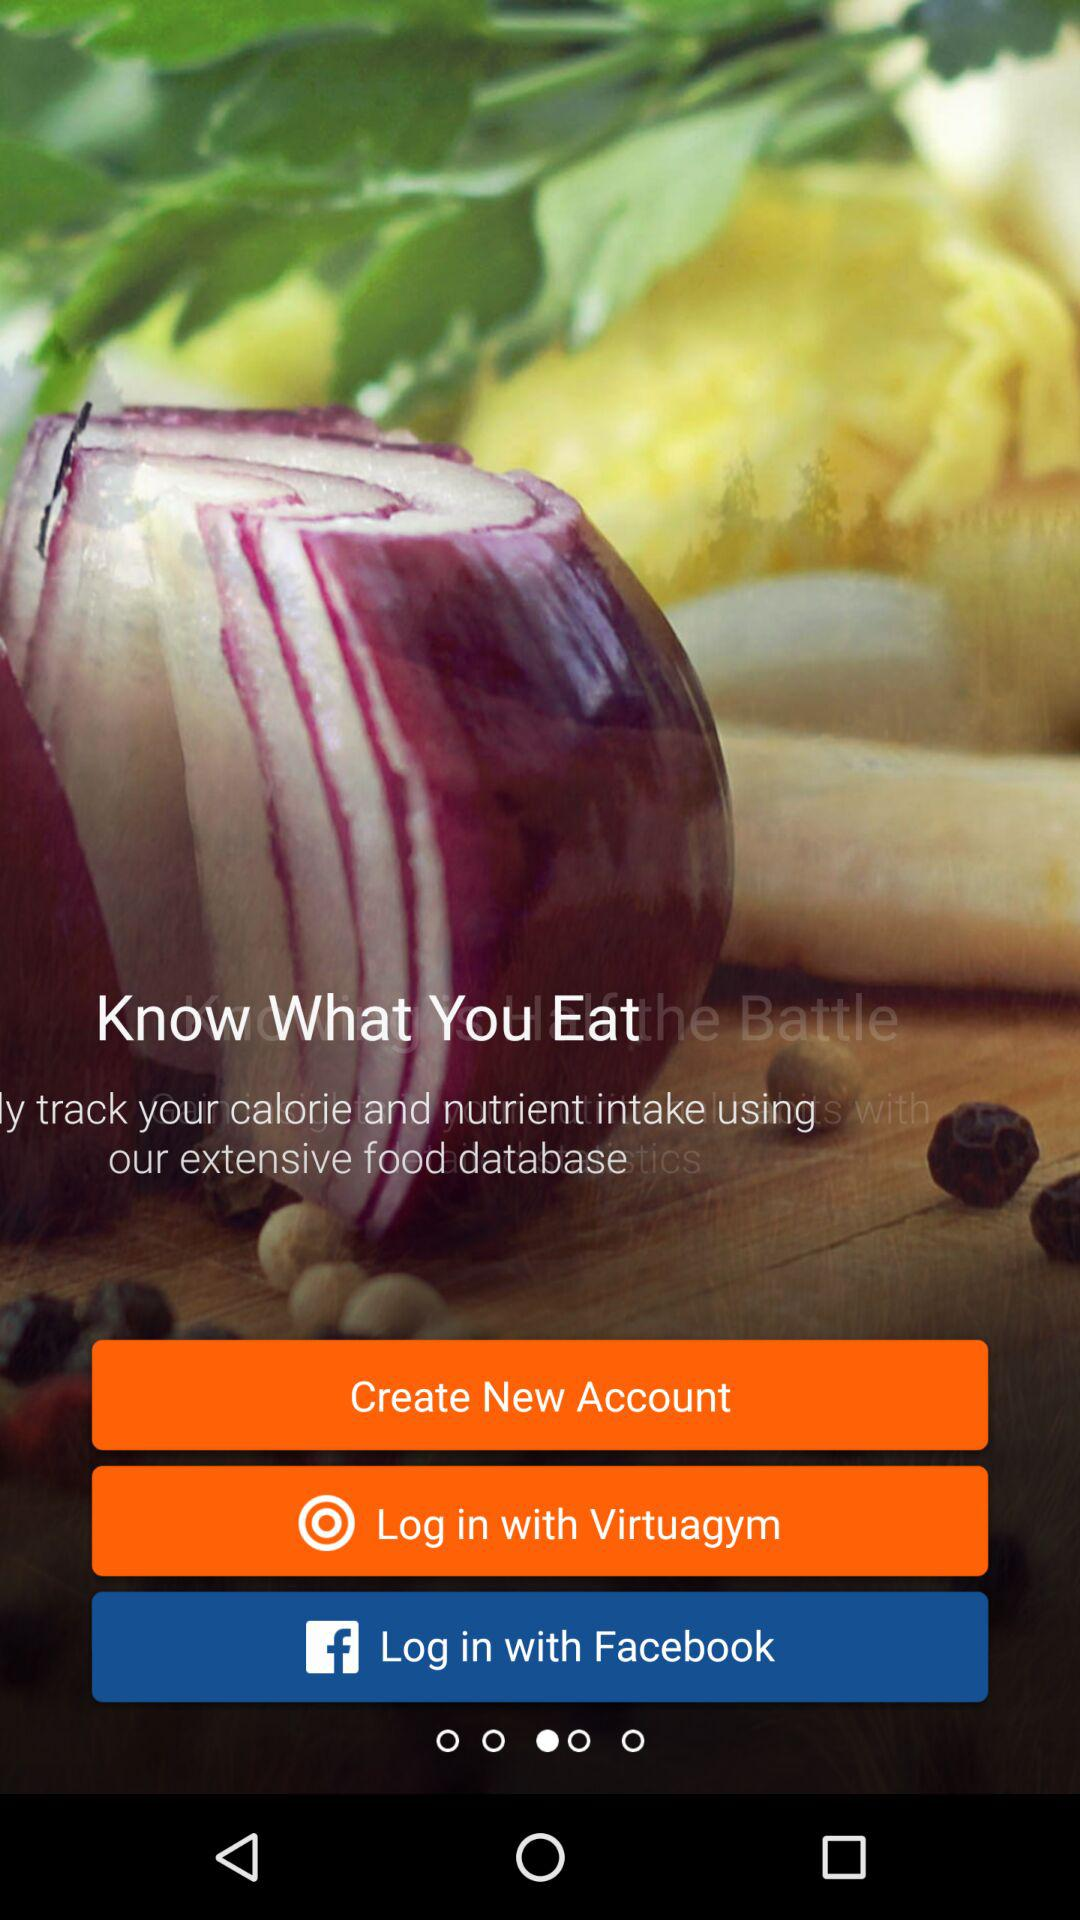Which are the different login options? The different login options are "Virtuagym" and "Facebook". 